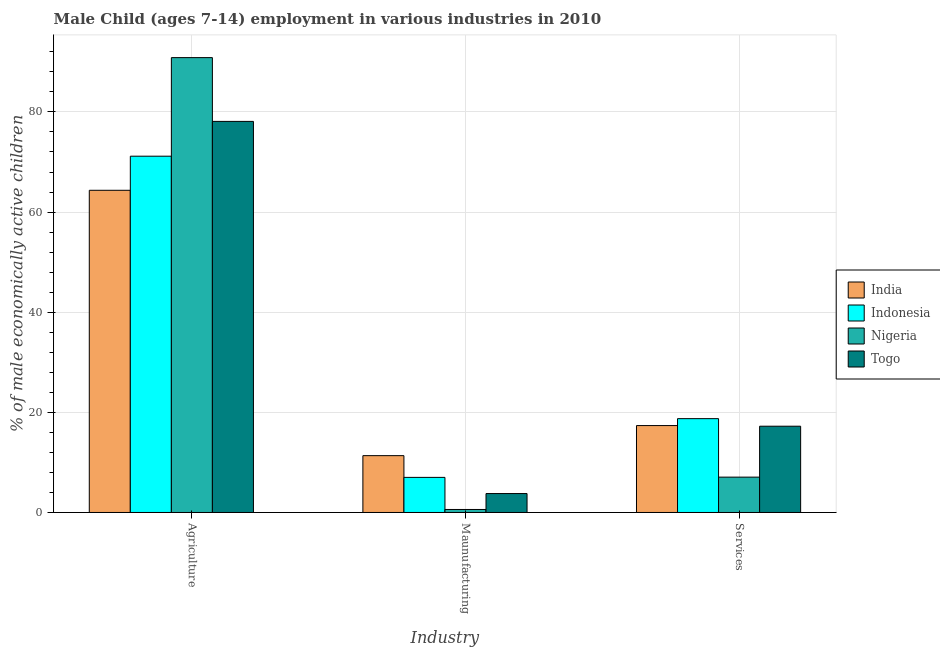What is the label of the 3rd group of bars from the left?
Your response must be concise. Services. What is the percentage of economically active children in services in Nigeria?
Provide a short and direct response. 7.06. Across all countries, what is the maximum percentage of economically active children in agriculture?
Provide a succinct answer. 90.85. Across all countries, what is the minimum percentage of economically active children in agriculture?
Offer a terse response. 64.35. In which country was the percentage of economically active children in services maximum?
Give a very brief answer. Indonesia. In which country was the percentage of economically active children in services minimum?
Provide a succinct answer. Nigeria. What is the total percentage of economically active children in manufacturing in the graph?
Provide a short and direct response. 22.74. What is the difference between the percentage of economically active children in services in Togo and that in Indonesia?
Your answer should be compact. -1.51. What is the difference between the percentage of economically active children in manufacturing in Indonesia and the percentage of economically active children in services in Nigeria?
Offer a terse response. -0.05. What is the average percentage of economically active children in services per country?
Provide a succinct answer. 15.1. What is the difference between the percentage of economically active children in services and percentage of economically active children in agriculture in Indonesia?
Your response must be concise. -52.42. In how many countries, is the percentage of economically active children in services greater than 52 %?
Your answer should be compact. 0. What is the ratio of the percentage of economically active children in services in Togo to that in Nigeria?
Offer a very short reply. 2.44. Is the percentage of economically active children in agriculture in India less than that in Indonesia?
Your answer should be compact. Yes. What is the difference between the highest and the second highest percentage of economically active children in manufacturing?
Offer a very short reply. 4.34. What is the difference between the highest and the lowest percentage of economically active children in services?
Your answer should be very brief. 11.68. What does the 2nd bar from the right in Services represents?
Give a very brief answer. Nigeria. Are all the bars in the graph horizontal?
Your answer should be very brief. No. How many countries are there in the graph?
Your answer should be compact. 4. What is the difference between two consecutive major ticks on the Y-axis?
Give a very brief answer. 20. Are the values on the major ticks of Y-axis written in scientific E-notation?
Offer a terse response. No. Where does the legend appear in the graph?
Your response must be concise. Center right. How many legend labels are there?
Provide a succinct answer. 4. How are the legend labels stacked?
Provide a succinct answer. Vertical. What is the title of the graph?
Your answer should be very brief. Male Child (ages 7-14) employment in various industries in 2010. What is the label or title of the X-axis?
Your response must be concise. Industry. What is the label or title of the Y-axis?
Give a very brief answer. % of male economically active children. What is the % of male economically active children in India in Agriculture?
Provide a short and direct response. 64.35. What is the % of male economically active children in Indonesia in Agriculture?
Provide a short and direct response. 71.16. What is the % of male economically active children in Nigeria in Agriculture?
Keep it short and to the point. 90.85. What is the % of male economically active children in Togo in Agriculture?
Offer a terse response. 78.11. What is the % of male economically active children of India in Maunufacturing?
Offer a terse response. 11.35. What is the % of male economically active children of Indonesia in Maunufacturing?
Your answer should be compact. 7.01. What is the % of male economically active children of Nigeria in Maunufacturing?
Ensure brevity in your answer.  0.6. What is the % of male economically active children in Togo in Maunufacturing?
Provide a succinct answer. 3.78. What is the % of male economically active children of India in Services?
Offer a terse response. 17.36. What is the % of male economically active children in Indonesia in Services?
Give a very brief answer. 18.74. What is the % of male economically active children of Nigeria in Services?
Make the answer very short. 7.06. What is the % of male economically active children in Togo in Services?
Your answer should be compact. 17.23. Across all Industry, what is the maximum % of male economically active children in India?
Make the answer very short. 64.35. Across all Industry, what is the maximum % of male economically active children in Indonesia?
Make the answer very short. 71.16. Across all Industry, what is the maximum % of male economically active children in Nigeria?
Make the answer very short. 90.85. Across all Industry, what is the maximum % of male economically active children of Togo?
Ensure brevity in your answer.  78.11. Across all Industry, what is the minimum % of male economically active children in India?
Your answer should be compact. 11.35. Across all Industry, what is the minimum % of male economically active children of Indonesia?
Provide a succinct answer. 7.01. Across all Industry, what is the minimum % of male economically active children in Togo?
Give a very brief answer. 3.78. What is the total % of male economically active children in India in the graph?
Keep it short and to the point. 93.06. What is the total % of male economically active children in Indonesia in the graph?
Ensure brevity in your answer.  96.91. What is the total % of male economically active children in Nigeria in the graph?
Provide a succinct answer. 98.51. What is the total % of male economically active children in Togo in the graph?
Your answer should be very brief. 99.12. What is the difference between the % of male economically active children in India in Agriculture and that in Maunufacturing?
Keep it short and to the point. 53. What is the difference between the % of male economically active children in Indonesia in Agriculture and that in Maunufacturing?
Provide a succinct answer. 64.15. What is the difference between the % of male economically active children of Nigeria in Agriculture and that in Maunufacturing?
Give a very brief answer. 90.25. What is the difference between the % of male economically active children in Togo in Agriculture and that in Maunufacturing?
Your answer should be compact. 74.33. What is the difference between the % of male economically active children of India in Agriculture and that in Services?
Keep it short and to the point. 46.99. What is the difference between the % of male economically active children in Indonesia in Agriculture and that in Services?
Ensure brevity in your answer.  52.42. What is the difference between the % of male economically active children of Nigeria in Agriculture and that in Services?
Keep it short and to the point. 83.79. What is the difference between the % of male economically active children of Togo in Agriculture and that in Services?
Give a very brief answer. 60.88. What is the difference between the % of male economically active children of India in Maunufacturing and that in Services?
Offer a terse response. -6.01. What is the difference between the % of male economically active children in Indonesia in Maunufacturing and that in Services?
Make the answer very short. -11.73. What is the difference between the % of male economically active children of Nigeria in Maunufacturing and that in Services?
Offer a very short reply. -6.46. What is the difference between the % of male economically active children of Togo in Maunufacturing and that in Services?
Your answer should be compact. -13.45. What is the difference between the % of male economically active children in India in Agriculture and the % of male economically active children in Indonesia in Maunufacturing?
Provide a short and direct response. 57.34. What is the difference between the % of male economically active children of India in Agriculture and the % of male economically active children of Nigeria in Maunufacturing?
Give a very brief answer. 63.75. What is the difference between the % of male economically active children of India in Agriculture and the % of male economically active children of Togo in Maunufacturing?
Offer a terse response. 60.57. What is the difference between the % of male economically active children in Indonesia in Agriculture and the % of male economically active children in Nigeria in Maunufacturing?
Make the answer very short. 70.56. What is the difference between the % of male economically active children in Indonesia in Agriculture and the % of male economically active children in Togo in Maunufacturing?
Your answer should be very brief. 67.38. What is the difference between the % of male economically active children of Nigeria in Agriculture and the % of male economically active children of Togo in Maunufacturing?
Offer a terse response. 87.07. What is the difference between the % of male economically active children of India in Agriculture and the % of male economically active children of Indonesia in Services?
Provide a short and direct response. 45.61. What is the difference between the % of male economically active children of India in Agriculture and the % of male economically active children of Nigeria in Services?
Provide a short and direct response. 57.29. What is the difference between the % of male economically active children of India in Agriculture and the % of male economically active children of Togo in Services?
Your answer should be compact. 47.12. What is the difference between the % of male economically active children in Indonesia in Agriculture and the % of male economically active children in Nigeria in Services?
Your response must be concise. 64.1. What is the difference between the % of male economically active children in Indonesia in Agriculture and the % of male economically active children in Togo in Services?
Keep it short and to the point. 53.93. What is the difference between the % of male economically active children of Nigeria in Agriculture and the % of male economically active children of Togo in Services?
Your response must be concise. 73.62. What is the difference between the % of male economically active children of India in Maunufacturing and the % of male economically active children of Indonesia in Services?
Provide a short and direct response. -7.39. What is the difference between the % of male economically active children of India in Maunufacturing and the % of male economically active children of Nigeria in Services?
Ensure brevity in your answer.  4.29. What is the difference between the % of male economically active children of India in Maunufacturing and the % of male economically active children of Togo in Services?
Offer a very short reply. -5.88. What is the difference between the % of male economically active children in Indonesia in Maunufacturing and the % of male economically active children in Nigeria in Services?
Offer a terse response. -0.05. What is the difference between the % of male economically active children of Indonesia in Maunufacturing and the % of male economically active children of Togo in Services?
Provide a short and direct response. -10.22. What is the difference between the % of male economically active children in Nigeria in Maunufacturing and the % of male economically active children in Togo in Services?
Your response must be concise. -16.63. What is the average % of male economically active children in India per Industry?
Give a very brief answer. 31.02. What is the average % of male economically active children in Indonesia per Industry?
Keep it short and to the point. 32.3. What is the average % of male economically active children of Nigeria per Industry?
Give a very brief answer. 32.84. What is the average % of male economically active children in Togo per Industry?
Offer a terse response. 33.04. What is the difference between the % of male economically active children of India and % of male economically active children of Indonesia in Agriculture?
Offer a terse response. -6.81. What is the difference between the % of male economically active children in India and % of male economically active children in Nigeria in Agriculture?
Your answer should be compact. -26.5. What is the difference between the % of male economically active children in India and % of male economically active children in Togo in Agriculture?
Your answer should be very brief. -13.76. What is the difference between the % of male economically active children of Indonesia and % of male economically active children of Nigeria in Agriculture?
Provide a succinct answer. -19.69. What is the difference between the % of male economically active children in Indonesia and % of male economically active children in Togo in Agriculture?
Your response must be concise. -6.95. What is the difference between the % of male economically active children in Nigeria and % of male economically active children in Togo in Agriculture?
Make the answer very short. 12.74. What is the difference between the % of male economically active children of India and % of male economically active children of Indonesia in Maunufacturing?
Provide a succinct answer. 4.34. What is the difference between the % of male economically active children of India and % of male economically active children of Nigeria in Maunufacturing?
Provide a short and direct response. 10.75. What is the difference between the % of male economically active children in India and % of male economically active children in Togo in Maunufacturing?
Your answer should be compact. 7.57. What is the difference between the % of male economically active children of Indonesia and % of male economically active children of Nigeria in Maunufacturing?
Keep it short and to the point. 6.41. What is the difference between the % of male economically active children of Indonesia and % of male economically active children of Togo in Maunufacturing?
Your response must be concise. 3.23. What is the difference between the % of male economically active children of Nigeria and % of male economically active children of Togo in Maunufacturing?
Offer a terse response. -3.18. What is the difference between the % of male economically active children in India and % of male economically active children in Indonesia in Services?
Provide a succinct answer. -1.38. What is the difference between the % of male economically active children of India and % of male economically active children of Togo in Services?
Your response must be concise. 0.13. What is the difference between the % of male economically active children in Indonesia and % of male economically active children in Nigeria in Services?
Keep it short and to the point. 11.68. What is the difference between the % of male economically active children in Indonesia and % of male economically active children in Togo in Services?
Your response must be concise. 1.51. What is the difference between the % of male economically active children of Nigeria and % of male economically active children of Togo in Services?
Your answer should be compact. -10.17. What is the ratio of the % of male economically active children of India in Agriculture to that in Maunufacturing?
Provide a succinct answer. 5.67. What is the ratio of the % of male economically active children in Indonesia in Agriculture to that in Maunufacturing?
Your answer should be compact. 10.15. What is the ratio of the % of male economically active children of Nigeria in Agriculture to that in Maunufacturing?
Provide a short and direct response. 151.42. What is the ratio of the % of male economically active children of Togo in Agriculture to that in Maunufacturing?
Your answer should be very brief. 20.66. What is the ratio of the % of male economically active children of India in Agriculture to that in Services?
Your response must be concise. 3.71. What is the ratio of the % of male economically active children of Indonesia in Agriculture to that in Services?
Give a very brief answer. 3.8. What is the ratio of the % of male economically active children of Nigeria in Agriculture to that in Services?
Ensure brevity in your answer.  12.87. What is the ratio of the % of male economically active children of Togo in Agriculture to that in Services?
Ensure brevity in your answer.  4.53. What is the ratio of the % of male economically active children of India in Maunufacturing to that in Services?
Your response must be concise. 0.65. What is the ratio of the % of male economically active children in Indonesia in Maunufacturing to that in Services?
Offer a terse response. 0.37. What is the ratio of the % of male economically active children in Nigeria in Maunufacturing to that in Services?
Your answer should be very brief. 0.09. What is the ratio of the % of male economically active children of Togo in Maunufacturing to that in Services?
Keep it short and to the point. 0.22. What is the difference between the highest and the second highest % of male economically active children of India?
Your answer should be very brief. 46.99. What is the difference between the highest and the second highest % of male economically active children of Indonesia?
Provide a short and direct response. 52.42. What is the difference between the highest and the second highest % of male economically active children of Nigeria?
Ensure brevity in your answer.  83.79. What is the difference between the highest and the second highest % of male economically active children in Togo?
Offer a terse response. 60.88. What is the difference between the highest and the lowest % of male economically active children of India?
Your answer should be compact. 53. What is the difference between the highest and the lowest % of male economically active children in Indonesia?
Offer a terse response. 64.15. What is the difference between the highest and the lowest % of male economically active children of Nigeria?
Offer a very short reply. 90.25. What is the difference between the highest and the lowest % of male economically active children of Togo?
Give a very brief answer. 74.33. 